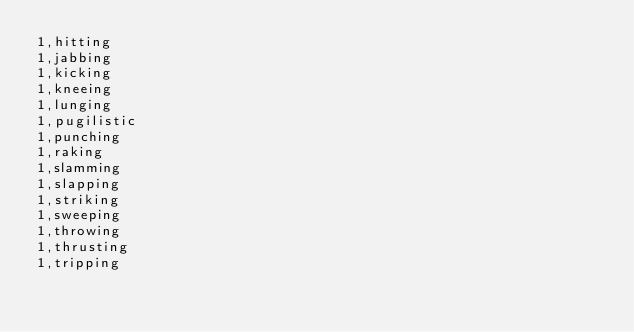Convert code to text. <code><loc_0><loc_0><loc_500><loc_500><_SQL_>1,hitting
1,jabbing
1,kicking
1,kneeing
1,lunging
1,pugilistic
1,punching
1,raking
1,slamming
1,slapping
1,striking
1,sweeping
1,throwing
1,thrusting
1,tripping</code> 